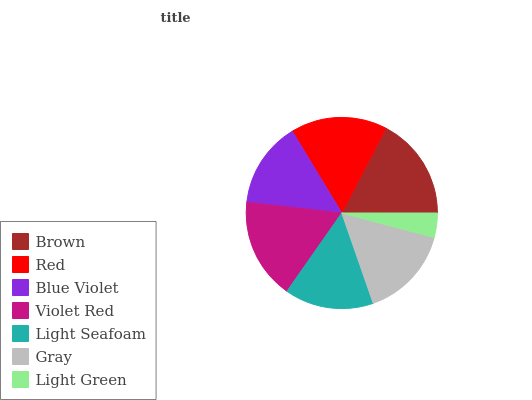Is Light Green the minimum?
Answer yes or no. Yes. Is Brown the maximum?
Answer yes or no. Yes. Is Red the minimum?
Answer yes or no. No. Is Red the maximum?
Answer yes or no. No. Is Brown greater than Red?
Answer yes or no. Yes. Is Red less than Brown?
Answer yes or no. Yes. Is Red greater than Brown?
Answer yes or no. No. Is Brown less than Red?
Answer yes or no. No. Is Gray the high median?
Answer yes or no. Yes. Is Gray the low median?
Answer yes or no. Yes. Is Light Seafoam the high median?
Answer yes or no. No. Is Blue Violet the low median?
Answer yes or no. No. 